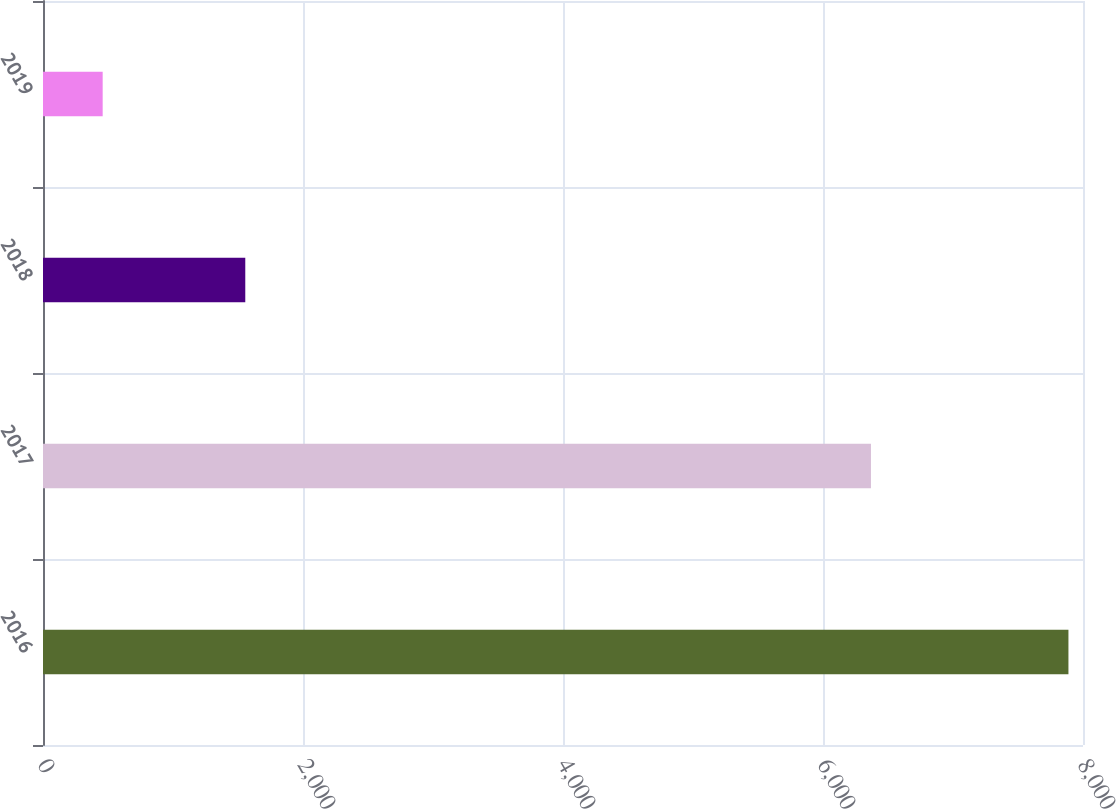<chart> <loc_0><loc_0><loc_500><loc_500><bar_chart><fcel>2016<fcel>2017<fcel>2018<fcel>2019<nl><fcel>7888<fcel>6369<fcel>1556<fcel>459<nl></chart> 